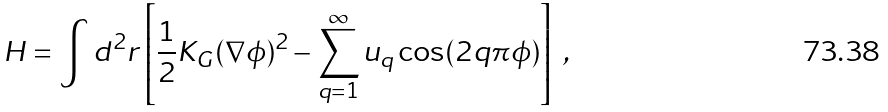Convert formula to latex. <formula><loc_0><loc_0><loc_500><loc_500>H = \int d ^ { 2 } { r } \left [ \frac { 1 } { 2 } K _ { G } ( \nabla \phi ) ^ { 2 } - \sum _ { q = 1 } ^ { \infty } u _ { q } \cos ( 2 q \pi \phi ) \right ] \ ,</formula> 